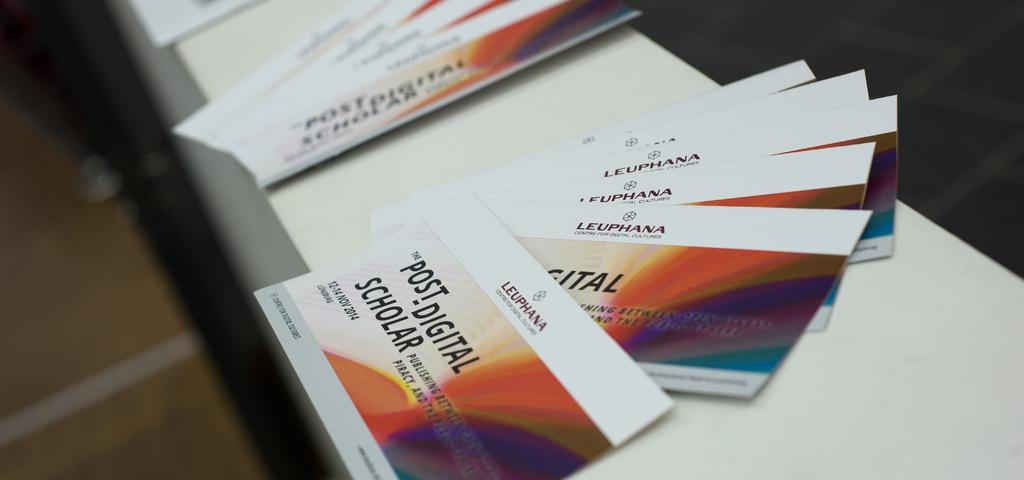<image>
Describe the image concisely. A few business cards that say Leuphana Post- 